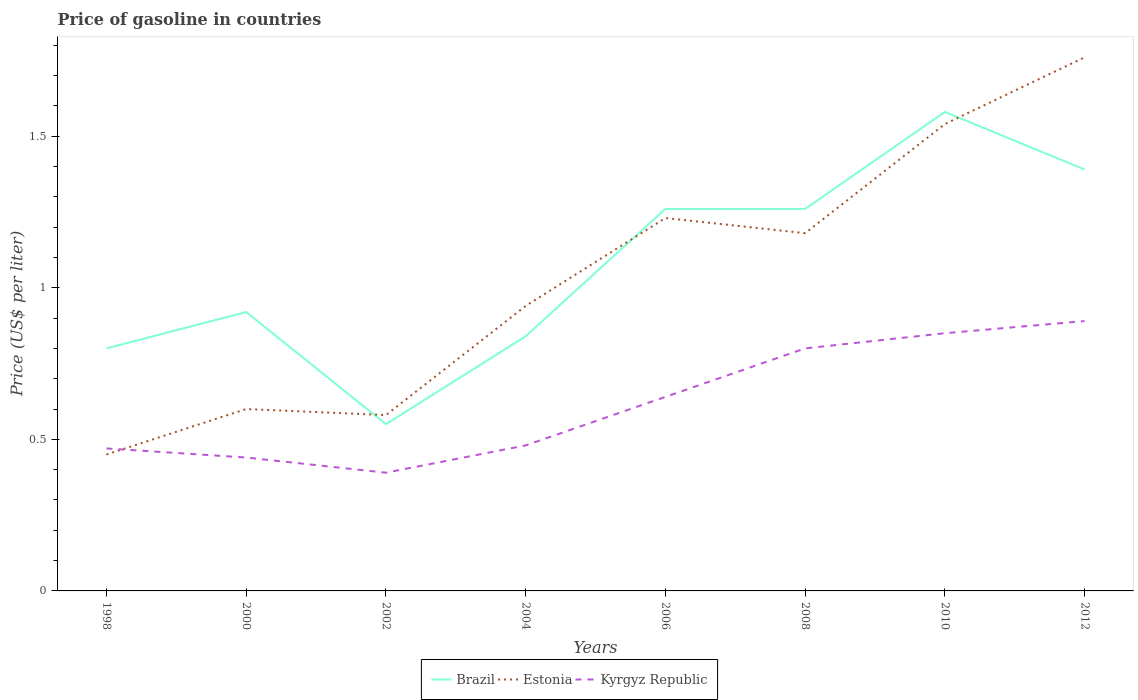How many different coloured lines are there?
Make the answer very short. 3. Does the line corresponding to Kyrgyz Republic intersect with the line corresponding to Estonia?
Your answer should be very brief. Yes. Is the number of lines equal to the number of legend labels?
Provide a short and direct response. Yes. Across all years, what is the maximum price of gasoline in Estonia?
Offer a very short reply. 0.45. In which year was the price of gasoline in Kyrgyz Republic maximum?
Your answer should be very brief. 2002. What is the total price of gasoline in Estonia in the graph?
Provide a short and direct response. -0.65. What is the difference between the highest and the second highest price of gasoline in Kyrgyz Republic?
Offer a very short reply. 0.5. Is the price of gasoline in Brazil strictly greater than the price of gasoline in Estonia over the years?
Make the answer very short. No. How many years are there in the graph?
Your answer should be compact. 8. Does the graph contain grids?
Offer a very short reply. No. Where does the legend appear in the graph?
Offer a very short reply. Bottom center. How many legend labels are there?
Your answer should be very brief. 3. How are the legend labels stacked?
Your response must be concise. Horizontal. What is the title of the graph?
Provide a short and direct response. Price of gasoline in countries. Does "Cambodia" appear as one of the legend labels in the graph?
Keep it short and to the point. No. What is the label or title of the Y-axis?
Provide a succinct answer. Price (US$ per liter). What is the Price (US$ per liter) of Estonia in 1998?
Give a very brief answer. 0.45. What is the Price (US$ per liter) in Kyrgyz Republic in 1998?
Ensure brevity in your answer.  0.47. What is the Price (US$ per liter) of Kyrgyz Republic in 2000?
Keep it short and to the point. 0.44. What is the Price (US$ per liter) in Brazil in 2002?
Offer a very short reply. 0.55. What is the Price (US$ per liter) in Estonia in 2002?
Offer a terse response. 0.58. What is the Price (US$ per liter) in Kyrgyz Republic in 2002?
Give a very brief answer. 0.39. What is the Price (US$ per liter) in Brazil in 2004?
Your response must be concise. 0.84. What is the Price (US$ per liter) of Kyrgyz Republic in 2004?
Keep it short and to the point. 0.48. What is the Price (US$ per liter) of Brazil in 2006?
Give a very brief answer. 1.26. What is the Price (US$ per liter) in Estonia in 2006?
Your answer should be compact. 1.23. What is the Price (US$ per liter) of Kyrgyz Republic in 2006?
Your answer should be compact. 0.64. What is the Price (US$ per liter) of Brazil in 2008?
Offer a terse response. 1.26. What is the Price (US$ per liter) in Estonia in 2008?
Your answer should be compact. 1.18. What is the Price (US$ per liter) of Brazil in 2010?
Keep it short and to the point. 1.58. What is the Price (US$ per liter) in Estonia in 2010?
Provide a succinct answer. 1.54. What is the Price (US$ per liter) in Kyrgyz Republic in 2010?
Provide a succinct answer. 0.85. What is the Price (US$ per liter) of Brazil in 2012?
Your answer should be compact. 1.39. What is the Price (US$ per liter) of Estonia in 2012?
Keep it short and to the point. 1.76. What is the Price (US$ per liter) in Kyrgyz Republic in 2012?
Offer a terse response. 0.89. Across all years, what is the maximum Price (US$ per liter) of Brazil?
Your answer should be compact. 1.58. Across all years, what is the maximum Price (US$ per liter) of Estonia?
Keep it short and to the point. 1.76. Across all years, what is the maximum Price (US$ per liter) of Kyrgyz Republic?
Ensure brevity in your answer.  0.89. Across all years, what is the minimum Price (US$ per liter) in Brazil?
Offer a very short reply. 0.55. Across all years, what is the minimum Price (US$ per liter) of Estonia?
Make the answer very short. 0.45. Across all years, what is the minimum Price (US$ per liter) of Kyrgyz Republic?
Ensure brevity in your answer.  0.39. What is the total Price (US$ per liter) in Brazil in the graph?
Keep it short and to the point. 8.6. What is the total Price (US$ per liter) in Estonia in the graph?
Your answer should be compact. 8.28. What is the total Price (US$ per liter) in Kyrgyz Republic in the graph?
Offer a very short reply. 4.96. What is the difference between the Price (US$ per liter) of Brazil in 1998 and that in 2000?
Offer a very short reply. -0.12. What is the difference between the Price (US$ per liter) in Kyrgyz Republic in 1998 and that in 2000?
Keep it short and to the point. 0.03. What is the difference between the Price (US$ per liter) in Brazil in 1998 and that in 2002?
Give a very brief answer. 0.25. What is the difference between the Price (US$ per liter) of Estonia in 1998 and that in 2002?
Offer a terse response. -0.13. What is the difference between the Price (US$ per liter) in Kyrgyz Republic in 1998 and that in 2002?
Make the answer very short. 0.08. What is the difference between the Price (US$ per liter) in Brazil in 1998 and that in 2004?
Your answer should be compact. -0.04. What is the difference between the Price (US$ per liter) in Estonia in 1998 and that in 2004?
Keep it short and to the point. -0.49. What is the difference between the Price (US$ per liter) of Kyrgyz Republic in 1998 and that in 2004?
Your answer should be compact. -0.01. What is the difference between the Price (US$ per liter) of Brazil in 1998 and that in 2006?
Give a very brief answer. -0.46. What is the difference between the Price (US$ per liter) of Estonia in 1998 and that in 2006?
Your answer should be very brief. -0.78. What is the difference between the Price (US$ per liter) in Kyrgyz Republic in 1998 and that in 2006?
Provide a short and direct response. -0.17. What is the difference between the Price (US$ per liter) in Brazil in 1998 and that in 2008?
Provide a short and direct response. -0.46. What is the difference between the Price (US$ per liter) in Estonia in 1998 and that in 2008?
Keep it short and to the point. -0.73. What is the difference between the Price (US$ per liter) in Kyrgyz Republic in 1998 and that in 2008?
Ensure brevity in your answer.  -0.33. What is the difference between the Price (US$ per liter) in Brazil in 1998 and that in 2010?
Your response must be concise. -0.78. What is the difference between the Price (US$ per liter) in Estonia in 1998 and that in 2010?
Give a very brief answer. -1.09. What is the difference between the Price (US$ per liter) in Kyrgyz Republic in 1998 and that in 2010?
Give a very brief answer. -0.38. What is the difference between the Price (US$ per liter) in Brazil in 1998 and that in 2012?
Offer a terse response. -0.59. What is the difference between the Price (US$ per liter) in Estonia in 1998 and that in 2012?
Offer a terse response. -1.31. What is the difference between the Price (US$ per liter) of Kyrgyz Republic in 1998 and that in 2012?
Provide a succinct answer. -0.42. What is the difference between the Price (US$ per liter) of Brazil in 2000 and that in 2002?
Keep it short and to the point. 0.37. What is the difference between the Price (US$ per liter) of Estonia in 2000 and that in 2002?
Your response must be concise. 0.02. What is the difference between the Price (US$ per liter) of Brazil in 2000 and that in 2004?
Make the answer very short. 0.08. What is the difference between the Price (US$ per liter) of Estonia in 2000 and that in 2004?
Your answer should be compact. -0.34. What is the difference between the Price (US$ per liter) of Kyrgyz Republic in 2000 and that in 2004?
Provide a succinct answer. -0.04. What is the difference between the Price (US$ per liter) of Brazil in 2000 and that in 2006?
Make the answer very short. -0.34. What is the difference between the Price (US$ per liter) in Estonia in 2000 and that in 2006?
Keep it short and to the point. -0.63. What is the difference between the Price (US$ per liter) of Kyrgyz Republic in 2000 and that in 2006?
Your answer should be very brief. -0.2. What is the difference between the Price (US$ per liter) in Brazil in 2000 and that in 2008?
Provide a short and direct response. -0.34. What is the difference between the Price (US$ per liter) of Estonia in 2000 and that in 2008?
Make the answer very short. -0.58. What is the difference between the Price (US$ per liter) in Kyrgyz Republic in 2000 and that in 2008?
Your answer should be compact. -0.36. What is the difference between the Price (US$ per liter) of Brazil in 2000 and that in 2010?
Your response must be concise. -0.66. What is the difference between the Price (US$ per liter) in Estonia in 2000 and that in 2010?
Your response must be concise. -0.94. What is the difference between the Price (US$ per liter) in Kyrgyz Republic in 2000 and that in 2010?
Keep it short and to the point. -0.41. What is the difference between the Price (US$ per liter) in Brazil in 2000 and that in 2012?
Provide a short and direct response. -0.47. What is the difference between the Price (US$ per liter) of Estonia in 2000 and that in 2012?
Your answer should be compact. -1.16. What is the difference between the Price (US$ per liter) in Kyrgyz Republic in 2000 and that in 2012?
Your response must be concise. -0.45. What is the difference between the Price (US$ per liter) of Brazil in 2002 and that in 2004?
Ensure brevity in your answer.  -0.29. What is the difference between the Price (US$ per liter) in Estonia in 2002 and that in 2004?
Make the answer very short. -0.36. What is the difference between the Price (US$ per liter) of Kyrgyz Republic in 2002 and that in 2004?
Keep it short and to the point. -0.09. What is the difference between the Price (US$ per liter) in Brazil in 2002 and that in 2006?
Provide a succinct answer. -0.71. What is the difference between the Price (US$ per liter) in Estonia in 2002 and that in 2006?
Offer a very short reply. -0.65. What is the difference between the Price (US$ per liter) in Brazil in 2002 and that in 2008?
Offer a very short reply. -0.71. What is the difference between the Price (US$ per liter) in Kyrgyz Republic in 2002 and that in 2008?
Provide a succinct answer. -0.41. What is the difference between the Price (US$ per liter) of Brazil in 2002 and that in 2010?
Give a very brief answer. -1.03. What is the difference between the Price (US$ per liter) of Estonia in 2002 and that in 2010?
Ensure brevity in your answer.  -0.96. What is the difference between the Price (US$ per liter) of Kyrgyz Republic in 2002 and that in 2010?
Ensure brevity in your answer.  -0.46. What is the difference between the Price (US$ per liter) in Brazil in 2002 and that in 2012?
Offer a terse response. -0.84. What is the difference between the Price (US$ per liter) in Estonia in 2002 and that in 2012?
Offer a very short reply. -1.18. What is the difference between the Price (US$ per liter) of Brazil in 2004 and that in 2006?
Provide a succinct answer. -0.42. What is the difference between the Price (US$ per liter) in Estonia in 2004 and that in 2006?
Your answer should be very brief. -0.29. What is the difference between the Price (US$ per liter) of Kyrgyz Republic in 2004 and that in 2006?
Your answer should be very brief. -0.16. What is the difference between the Price (US$ per liter) of Brazil in 2004 and that in 2008?
Your answer should be very brief. -0.42. What is the difference between the Price (US$ per liter) in Estonia in 2004 and that in 2008?
Provide a succinct answer. -0.24. What is the difference between the Price (US$ per liter) of Kyrgyz Republic in 2004 and that in 2008?
Your response must be concise. -0.32. What is the difference between the Price (US$ per liter) of Brazil in 2004 and that in 2010?
Your answer should be compact. -0.74. What is the difference between the Price (US$ per liter) in Estonia in 2004 and that in 2010?
Your response must be concise. -0.6. What is the difference between the Price (US$ per liter) in Kyrgyz Republic in 2004 and that in 2010?
Offer a very short reply. -0.37. What is the difference between the Price (US$ per liter) in Brazil in 2004 and that in 2012?
Offer a very short reply. -0.55. What is the difference between the Price (US$ per liter) of Estonia in 2004 and that in 2012?
Make the answer very short. -0.82. What is the difference between the Price (US$ per liter) in Kyrgyz Republic in 2004 and that in 2012?
Ensure brevity in your answer.  -0.41. What is the difference between the Price (US$ per liter) of Brazil in 2006 and that in 2008?
Provide a succinct answer. 0. What is the difference between the Price (US$ per liter) in Kyrgyz Republic in 2006 and that in 2008?
Provide a short and direct response. -0.16. What is the difference between the Price (US$ per liter) of Brazil in 2006 and that in 2010?
Your answer should be very brief. -0.32. What is the difference between the Price (US$ per liter) in Estonia in 2006 and that in 2010?
Your answer should be compact. -0.31. What is the difference between the Price (US$ per liter) of Kyrgyz Republic in 2006 and that in 2010?
Ensure brevity in your answer.  -0.21. What is the difference between the Price (US$ per liter) of Brazil in 2006 and that in 2012?
Provide a short and direct response. -0.13. What is the difference between the Price (US$ per liter) of Estonia in 2006 and that in 2012?
Your response must be concise. -0.53. What is the difference between the Price (US$ per liter) of Kyrgyz Republic in 2006 and that in 2012?
Give a very brief answer. -0.25. What is the difference between the Price (US$ per liter) in Brazil in 2008 and that in 2010?
Keep it short and to the point. -0.32. What is the difference between the Price (US$ per liter) of Estonia in 2008 and that in 2010?
Offer a very short reply. -0.36. What is the difference between the Price (US$ per liter) of Brazil in 2008 and that in 2012?
Your answer should be compact. -0.13. What is the difference between the Price (US$ per liter) in Estonia in 2008 and that in 2012?
Provide a succinct answer. -0.58. What is the difference between the Price (US$ per liter) in Kyrgyz Republic in 2008 and that in 2012?
Keep it short and to the point. -0.09. What is the difference between the Price (US$ per liter) in Brazil in 2010 and that in 2012?
Offer a terse response. 0.19. What is the difference between the Price (US$ per liter) of Estonia in 2010 and that in 2012?
Offer a very short reply. -0.22. What is the difference between the Price (US$ per liter) of Kyrgyz Republic in 2010 and that in 2012?
Your response must be concise. -0.04. What is the difference between the Price (US$ per liter) in Brazil in 1998 and the Price (US$ per liter) in Kyrgyz Republic in 2000?
Your answer should be very brief. 0.36. What is the difference between the Price (US$ per liter) in Estonia in 1998 and the Price (US$ per liter) in Kyrgyz Republic in 2000?
Provide a short and direct response. 0.01. What is the difference between the Price (US$ per liter) of Brazil in 1998 and the Price (US$ per liter) of Estonia in 2002?
Offer a terse response. 0.22. What is the difference between the Price (US$ per liter) of Brazil in 1998 and the Price (US$ per liter) of Kyrgyz Republic in 2002?
Offer a very short reply. 0.41. What is the difference between the Price (US$ per liter) in Estonia in 1998 and the Price (US$ per liter) in Kyrgyz Republic in 2002?
Ensure brevity in your answer.  0.06. What is the difference between the Price (US$ per liter) in Brazil in 1998 and the Price (US$ per liter) in Estonia in 2004?
Offer a very short reply. -0.14. What is the difference between the Price (US$ per liter) of Brazil in 1998 and the Price (US$ per liter) of Kyrgyz Republic in 2004?
Make the answer very short. 0.32. What is the difference between the Price (US$ per liter) in Estonia in 1998 and the Price (US$ per liter) in Kyrgyz Republic in 2004?
Keep it short and to the point. -0.03. What is the difference between the Price (US$ per liter) of Brazil in 1998 and the Price (US$ per liter) of Estonia in 2006?
Give a very brief answer. -0.43. What is the difference between the Price (US$ per liter) of Brazil in 1998 and the Price (US$ per liter) of Kyrgyz Republic in 2006?
Your answer should be very brief. 0.16. What is the difference between the Price (US$ per liter) of Estonia in 1998 and the Price (US$ per liter) of Kyrgyz Republic in 2006?
Offer a very short reply. -0.19. What is the difference between the Price (US$ per liter) of Brazil in 1998 and the Price (US$ per liter) of Estonia in 2008?
Provide a short and direct response. -0.38. What is the difference between the Price (US$ per liter) in Estonia in 1998 and the Price (US$ per liter) in Kyrgyz Republic in 2008?
Ensure brevity in your answer.  -0.35. What is the difference between the Price (US$ per liter) of Brazil in 1998 and the Price (US$ per liter) of Estonia in 2010?
Keep it short and to the point. -0.74. What is the difference between the Price (US$ per liter) in Brazil in 1998 and the Price (US$ per liter) in Estonia in 2012?
Ensure brevity in your answer.  -0.96. What is the difference between the Price (US$ per liter) in Brazil in 1998 and the Price (US$ per liter) in Kyrgyz Republic in 2012?
Your answer should be very brief. -0.09. What is the difference between the Price (US$ per liter) in Estonia in 1998 and the Price (US$ per liter) in Kyrgyz Republic in 2012?
Ensure brevity in your answer.  -0.44. What is the difference between the Price (US$ per liter) in Brazil in 2000 and the Price (US$ per liter) in Estonia in 2002?
Make the answer very short. 0.34. What is the difference between the Price (US$ per liter) of Brazil in 2000 and the Price (US$ per liter) of Kyrgyz Republic in 2002?
Your response must be concise. 0.53. What is the difference between the Price (US$ per liter) of Estonia in 2000 and the Price (US$ per liter) of Kyrgyz Republic in 2002?
Make the answer very short. 0.21. What is the difference between the Price (US$ per liter) of Brazil in 2000 and the Price (US$ per liter) of Estonia in 2004?
Provide a short and direct response. -0.02. What is the difference between the Price (US$ per liter) in Brazil in 2000 and the Price (US$ per liter) in Kyrgyz Republic in 2004?
Make the answer very short. 0.44. What is the difference between the Price (US$ per liter) of Estonia in 2000 and the Price (US$ per liter) of Kyrgyz Republic in 2004?
Give a very brief answer. 0.12. What is the difference between the Price (US$ per liter) of Brazil in 2000 and the Price (US$ per liter) of Estonia in 2006?
Provide a succinct answer. -0.31. What is the difference between the Price (US$ per liter) of Brazil in 2000 and the Price (US$ per liter) of Kyrgyz Republic in 2006?
Your answer should be very brief. 0.28. What is the difference between the Price (US$ per liter) of Estonia in 2000 and the Price (US$ per liter) of Kyrgyz Republic in 2006?
Your answer should be very brief. -0.04. What is the difference between the Price (US$ per liter) in Brazil in 2000 and the Price (US$ per liter) in Estonia in 2008?
Your response must be concise. -0.26. What is the difference between the Price (US$ per liter) of Brazil in 2000 and the Price (US$ per liter) of Kyrgyz Republic in 2008?
Your answer should be very brief. 0.12. What is the difference between the Price (US$ per liter) in Estonia in 2000 and the Price (US$ per liter) in Kyrgyz Republic in 2008?
Your answer should be compact. -0.2. What is the difference between the Price (US$ per liter) in Brazil in 2000 and the Price (US$ per liter) in Estonia in 2010?
Offer a terse response. -0.62. What is the difference between the Price (US$ per liter) of Brazil in 2000 and the Price (US$ per liter) of Kyrgyz Republic in 2010?
Make the answer very short. 0.07. What is the difference between the Price (US$ per liter) of Estonia in 2000 and the Price (US$ per liter) of Kyrgyz Republic in 2010?
Your response must be concise. -0.25. What is the difference between the Price (US$ per liter) of Brazil in 2000 and the Price (US$ per liter) of Estonia in 2012?
Ensure brevity in your answer.  -0.84. What is the difference between the Price (US$ per liter) of Estonia in 2000 and the Price (US$ per liter) of Kyrgyz Republic in 2012?
Your response must be concise. -0.29. What is the difference between the Price (US$ per liter) of Brazil in 2002 and the Price (US$ per liter) of Estonia in 2004?
Your answer should be very brief. -0.39. What is the difference between the Price (US$ per liter) of Brazil in 2002 and the Price (US$ per liter) of Kyrgyz Republic in 2004?
Ensure brevity in your answer.  0.07. What is the difference between the Price (US$ per liter) in Estonia in 2002 and the Price (US$ per liter) in Kyrgyz Republic in 2004?
Your answer should be compact. 0.1. What is the difference between the Price (US$ per liter) of Brazil in 2002 and the Price (US$ per liter) of Estonia in 2006?
Your answer should be compact. -0.68. What is the difference between the Price (US$ per liter) in Brazil in 2002 and the Price (US$ per liter) in Kyrgyz Republic in 2006?
Ensure brevity in your answer.  -0.09. What is the difference between the Price (US$ per liter) of Estonia in 2002 and the Price (US$ per liter) of Kyrgyz Republic in 2006?
Keep it short and to the point. -0.06. What is the difference between the Price (US$ per liter) of Brazil in 2002 and the Price (US$ per liter) of Estonia in 2008?
Keep it short and to the point. -0.63. What is the difference between the Price (US$ per liter) in Brazil in 2002 and the Price (US$ per liter) in Kyrgyz Republic in 2008?
Your response must be concise. -0.25. What is the difference between the Price (US$ per liter) of Estonia in 2002 and the Price (US$ per liter) of Kyrgyz Republic in 2008?
Offer a terse response. -0.22. What is the difference between the Price (US$ per liter) in Brazil in 2002 and the Price (US$ per liter) in Estonia in 2010?
Your answer should be compact. -0.99. What is the difference between the Price (US$ per liter) of Brazil in 2002 and the Price (US$ per liter) of Kyrgyz Republic in 2010?
Provide a succinct answer. -0.3. What is the difference between the Price (US$ per liter) in Estonia in 2002 and the Price (US$ per liter) in Kyrgyz Republic in 2010?
Offer a very short reply. -0.27. What is the difference between the Price (US$ per liter) in Brazil in 2002 and the Price (US$ per liter) in Estonia in 2012?
Make the answer very short. -1.21. What is the difference between the Price (US$ per liter) of Brazil in 2002 and the Price (US$ per liter) of Kyrgyz Republic in 2012?
Your response must be concise. -0.34. What is the difference between the Price (US$ per liter) of Estonia in 2002 and the Price (US$ per liter) of Kyrgyz Republic in 2012?
Provide a short and direct response. -0.31. What is the difference between the Price (US$ per liter) of Brazil in 2004 and the Price (US$ per liter) of Estonia in 2006?
Keep it short and to the point. -0.39. What is the difference between the Price (US$ per liter) of Brazil in 2004 and the Price (US$ per liter) of Kyrgyz Republic in 2006?
Give a very brief answer. 0.2. What is the difference between the Price (US$ per liter) of Brazil in 2004 and the Price (US$ per liter) of Estonia in 2008?
Offer a very short reply. -0.34. What is the difference between the Price (US$ per liter) of Estonia in 2004 and the Price (US$ per liter) of Kyrgyz Republic in 2008?
Give a very brief answer. 0.14. What is the difference between the Price (US$ per liter) of Brazil in 2004 and the Price (US$ per liter) of Estonia in 2010?
Give a very brief answer. -0.7. What is the difference between the Price (US$ per liter) in Brazil in 2004 and the Price (US$ per liter) in Kyrgyz Republic in 2010?
Provide a succinct answer. -0.01. What is the difference between the Price (US$ per liter) of Estonia in 2004 and the Price (US$ per liter) of Kyrgyz Republic in 2010?
Your answer should be very brief. 0.09. What is the difference between the Price (US$ per liter) in Brazil in 2004 and the Price (US$ per liter) in Estonia in 2012?
Offer a terse response. -0.92. What is the difference between the Price (US$ per liter) in Brazil in 2004 and the Price (US$ per liter) in Kyrgyz Republic in 2012?
Give a very brief answer. -0.05. What is the difference between the Price (US$ per liter) in Estonia in 2004 and the Price (US$ per liter) in Kyrgyz Republic in 2012?
Your answer should be compact. 0.05. What is the difference between the Price (US$ per liter) in Brazil in 2006 and the Price (US$ per liter) in Kyrgyz Republic in 2008?
Keep it short and to the point. 0.46. What is the difference between the Price (US$ per liter) in Estonia in 2006 and the Price (US$ per liter) in Kyrgyz Republic in 2008?
Provide a succinct answer. 0.43. What is the difference between the Price (US$ per liter) of Brazil in 2006 and the Price (US$ per liter) of Estonia in 2010?
Your response must be concise. -0.28. What is the difference between the Price (US$ per liter) of Brazil in 2006 and the Price (US$ per liter) of Kyrgyz Republic in 2010?
Your response must be concise. 0.41. What is the difference between the Price (US$ per liter) in Estonia in 2006 and the Price (US$ per liter) in Kyrgyz Republic in 2010?
Your answer should be very brief. 0.38. What is the difference between the Price (US$ per liter) of Brazil in 2006 and the Price (US$ per liter) of Estonia in 2012?
Make the answer very short. -0.5. What is the difference between the Price (US$ per liter) in Brazil in 2006 and the Price (US$ per liter) in Kyrgyz Republic in 2012?
Keep it short and to the point. 0.37. What is the difference between the Price (US$ per liter) in Estonia in 2006 and the Price (US$ per liter) in Kyrgyz Republic in 2012?
Make the answer very short. 0.34. What is the difference between the Price (US$ per liter) of Brazil in 2008 and the Price (US$ per liter) of Estonia in 2010?
Your answer should be compact. -0.28. What is the difference between the Price (US$ per liter) in Brazil in 2008 and the Price (US$ per liter) in Kyrgyz Republic in 2010?
Your response must be concise. 0.41. What is the difference between the Price (US$ per liter) in Estonia in 2008 and the Price (US$ per liter) in Kyrgyz Republic in 2010?
Offer a terse response. 0.33. What is the difference between the Price (US$ per liter) in Brazil in 2008 and the Price (US$ per liter) in Estonia in 2012?
Make the answer very short. -0.5. What is the difference between the Price (US$ per liter) of Brazil in 2008 and the Price (US$ per liter) of Kyrgyz Republic in 2012?
Provide a succinct answer. 0.37. What is the difference between the Price (US$ per liter) of Estonia in 2008 and the Price (US$ per liter) of Kyrgyz Republic in 2012?
Your response must be concise. 0.29. What is the difference between the Price (US$ per liter) of Brazil in 2010 and the Price (US$ per liter) of Estonia in 2012?
Provide a short and direct response. -0.18. What is the difference between the Price (US$ per liter) in Brazil in 2010 and the Price (US$ per liter) in Kyrgyz Republic in 2012?
Provide a succinct answer. 0.69. What is the difference between the Price (US$ per liter) in Estonia in 2010 and the Price (US$ per liter) in Kyrgyz Republic in 2012?
Offer a terse response. 0.65. What is the average Price (US$ per liter) of Brazil per year?
Your answer should be compact. 1.07. What is the average Price (US$ per liter) of Estonia per year?
Keep it short and to the point. 1.03. What is the average Price (US$ per liter) in Kyrgyz Republic per year?
Your answer should be very brief. 0.62. In the year 1998, what is the difference between the Price (US$ per liter) in Brazil and Price (US$ per liter) in Estonia?
Offer a very short reply. 0.35. In the year 1998, what is the difference between the Price (US$ per liter) of Brazil and Price (US$ per liter) of Kyrgyz Republic?
Provide a succinct answer. 0.33. In the year 1998, what is the difference between the Price (US$ per liter) of Estonia and Price (US$ per liter) of Kyrgyz Republic?
Give a very brief answer. -0.02. In the year 2000, what is the difference between the Price (US$ per liter) of Brazil and Price (US$ per liter) of Estonia?
Provide a short and direct response. 0.32. In the year 2000, what is the difference between the Price (US$ per liter) of Brazil and Price (US$ per liter) of Kyrgyz Republic?
Provide a succinct answer. 0.48. In the year 2000, what is the difference between the Price (US$ per liter) of Estonia and Price (US$ per liter) of Kyrgyz Republic?
Ensure brevity in your answer.  0.16. In the year 2002, what is the difference between the Price (US$ per liter) of Brazil and Price (US$ per liter) of Estonia?
Provide a short and direct response. -0.03. In the year 2002, what is the difference between the Price (US$ per liter) of Brazil and Price (US$ per liter) of Kyrgyz Republic?
Your response must be concise. 0.16. In the year 2002, what is the difference between the Price (US$ per liter) of Estonia and Price (US$ per liter) of Kyrgyz Republic?
Provide a succinct answer. 0.19. In the year 2004, what is the difference between the Price (US$ per liter) of Brazil and Price (US$ per liter) of Estonia?
Provide a succinct answer. -0.1. In the year 2004, what is the difference between the Price (US$ per liter) of Brazil and Price (US$ per liter) of Kyrgyz Republic?
Make the answer very short. 0.36. In the year 2004, what is the difference between the Price (US$ per liter) of Estonia and Price (US$ per liter) of Kyrgyz Republic?
Give a very brief answer. 0.46. In the year 2006, what is the difference between the Price (US$ per liter) in Brazil and Price (US$ per liter) in Estonia?
Keep it short and to the point. 0.03. In the year 2006, what is the difference between the Price (US$ per liter) in Brazil and Price (US$ per liter) in Kyrgyz Republic?
Your response must be concise. 0.62. In the year 2006, what is the difference between the Price (US$ per liter) in Estonia and Price (US$ per liter) in Kyrgyz Republic?
Ensure brevity in your answer.  0.59. In the year 2008, what is the difference between the Price (US$ per liter) of Brazil and Price (US$ per liter) of Kyrgyz Republic?
Offer a terse response. 0.46. In the year 2008, what is the difference between the Price (US$ per liter) of Estonia and Price (US$ per liter) of Kyrgyz Republic?
Your response must be concise. 0.38. In the year 2010, what is the difference between the Price (US$ per liter) of Brazil and Price (US$ per liter) of Kyrgyz Republic?
Provide a short and direct response. 0.73. In the year 2010, what is the difference between the Price (US$ per liter) in Estonia and Price (US$ per liter) in Kyrgyz Republic?
Your answer should be very brief. 0.69. In the year 2012, what is the difference between the Price (US$ per liter) of Brazil and Price (US$ per liter) of Estonia?
Make the answer very short. -0.37. In the year 2012, what is the difference between the Price (US$ per liter) of Estonia and Price (US$ per liter) of Kyrgyz Republic?
Your response must be concise. 0.87. What is the ratio of the Price (US$ per liter) of Brazil in 1998 to that in 2000?
Your answer should be compact. 0.87. What is the ratio of the Price (US$ per liter) of Estonia in 1998 to that in 2000?
Offer a very short reply. 0.75. What is the ratio of the Price (US$ per liter) of Kyrgyz Republic in 1998 to that in 2000?
Give a very brief answer. 1.07. What is the ratio of the Price (US$ per liter) of Brazil in 1998 to that in 2002?
Your response must be concise. 1.45. What is the ratio of the Price (US$ per liter) in Estonia in 1998 to that in 2002?
Give a very brief answer. 0.78. What is the ratio of the Price (US$ per liter) in Kyrgyz Republic in 1998 to that in 2002?
Make the answer very short. 1.21. What is the ratio of the Price (US$ per liter) of Brazil in 1998 to that in 2004?
Make the answer very short. 0.95. What is the ratio of the Price (US$ per liter) of Estonia in 1998 to that in 2004?
Offer a very short reply. 0.48. What is the ratio of the Price (US$ per liter) in Kyrgyz Republic in 1998 to that in 2004?
Offer a terse response. 0.98. What is the ratio of the Price (US$ per liter) of Brazil in 1998 to that in 2006?
Your response must be concise. 0.63. What is the ratio of the Price (US$ per liter) in Estonia in 1998 to that in 2006?
Provide a short and direct response. 0.37. What is the ratio of the Price (US$ per liter) of Kyrgyz Republic in 1998 to that in 2006?
Ensure brevity in your answer.  0.73. What is the ratio of the Price (US$ per liter) of Brazil in 1998 to that in 2008?
Your response must be concise. 0.63. What is the ratio of the Price (US$ per liter) in Estonia in 1998 to that in 2008?
Offer a very short reply. 0.38. What is the ratio of the Price (US$ per liter) in Kyrgyz Republic in 1998 to that in 2008?
Keep it short and to the point. 0.59. What is the ratio of the Price (US$ per liter) of Brazil in 1998 to that in 2010?
Give a very brief answer. 0.51. What is the ratio of the Price (US$ per liter) in Estonia in 1998 to that in 2010?
Offer a very short reply. 0.29. What is the ratio of the Price (US$ per liter) of Kyrgyz Republic in 1998 to that in 2010?
Ensure brevity in your answer.  0.55. What is the ratio of the Price (US$ per liter) in Brazil in 1998 to that in 2012?
Offer a terse response. 0.58. What is the ratio of the Price (US$ per liter) in Estonia in 1998 to that in 2012?
Your answer should be compact. 0.26. What is the ratio of the Price (US$ per liter) of Kyrgyz Republic in 1998 to that in 2012?
Your response must be concise. 0.53. What is the ratio of the Price (US$ per liter) in Brazil in 2000 to that in 2002?
Provide a succinct answer. 1.67. What is the ratio of the Price (US$ per liter) of Estonia in 2000 to that in 2002?
Provide a succinct answer. 1.03. What is the ratio of the Price (US$ per liter) in Kyrgyz Republic in 2000 to that in 2002?
Give a very brief answer. 1.13. What is the ratio of the Price (US$ per liter) in Brazil in 2000 to that in 2004?
Offer a very short reply. 1.1. What is the ratio of the Price (US$ per liter) in Estonia in 2000 to that in 2004?
Keep it short and to the point. 0.64. What is the ratio of the Price (US$ per liter) in Brazil in 2000 to that in 2006?
Give a very brief answer. 0.73. What is the ratio of the Price (US$ per liter) in Estonia in 2000 to that in 2006?
Your response must be concise. 0.49. What is the ratio of the Price (US$ per liter) of Kyrgyz Republic in 2000 to that in 2006?
Offer a terse response. 0.69. What is the ratio of the Price (US$ per liter) of Brazil in 2000 to that in 2008?
Make the answer very short. 0.73. What is the ratio of the Price (US$ per liter) in Estonia in 2000 to that in 2008?
Provide a succinct answer. 0.51. What is the ratio of the Price (US$ per liter) in Kyrgyz Republic in 2000 to that in 2008?
Keep it short and to the point. 0.55. What is the ratio of the Price (US$ per liter) of Brazil in 2000 to that in 2010?
Offer a very short reply. 0.58. What is the ratio of the Price (US$ per liter) in Estonia in 2000 to that in 2010?
Offer a very short reply. 0.39. What is the ratio of the Price (US$ per liter) in Kyrgyz Republic in 2000 to that in 2010?
Offer a terse response. 0.52. What is the ratio of the Price (US$ per liter) in Brazil in 2000 to that in 2012?
Offer a terse response. 0.66. What is the ratio of the Price (US$ per liter) in Estonia in 2000 to that in 2012?
Offer a very short reply. 0.34. What is the ratio of the Price (US$ per liter) in Kyrgyz Republic in 2000 to that in 2012?
Provide a succinct answer. 0.49. What is the ratio of the Price (US$ per liter) of Brazil in 2002 to that in 2004?
Keep it short and to the point. 0.65. What is the ratio of the Price (US$ per liter) in Estonia in 2002 to that in 2004?
Your response must be concise. 0.62. What is the ratio of the Price (US$ per liter) in Kyrgyz Republic in 2002 to that in 2004?
Make the answer very short. 0.81. What is the ratio of the Price (US$ per liter) of Brazil in 2002 to that in 2006?
Your answer should be compact. 0.44. What is the ratio of the Price (US$ per liter) in Estonia in 2002 to that in 2006?
Your answer should be very brief. 0.47. What is the ratio of the Price (US$ per liter) of Kyrgyz Republic in 2002 to that in 2006?
Make the answer very short. 0.61. What is the ratio of the Price (US$ per liter) in Brazil in 2002 to that in 2008?
Offer a very short reply. 0.44. What is the ratio of the Price (US$ per liter) of Estonia in 2002 to that in 2008?
Give a very brief answer. 0.49. What is the ratio of the Price (US$ per liter) in Kyrgyz Republic in 2002 to that in 2008?
Provide a succinct answer. 0.49. What is the ratio of the Price (US$ per liter) in Brazil in 2002 to that in 2010?
Offer a very short reply. 0.35. What is the ratio of the Price (US$ per liter) in Estonia in 2002 to that in 2010?
Ensure brevity in your answer.  0.38. What is the ratio of the Price (US$ per liter) in Kyrgyz Republic in 2002 to that in 2010?
Provide a succinct answer. 0.46. What is the ratio of the Price (US$ per liter) in Brazil in 2002 to that in 2012?
Keep it short and to the point. 0.4. What is the ratio of the Price (US$ per liter) of Estonia in 2002 to that in 2012?
Make the answer very short. 0.33. What is the ratio of the Price (US$ per liter) in Kyrgyz Republic in 2002 to that in 2012?
Keep it short and to the point. 0.44. What is the ratio of the Price (US$ per liter) of Estonia in 2004 to that in 2006?
Make the answer very short. 0.76. What is the ratio of the Price (US$ per liter) in Estonia in 2004 to that in 2008?
Your answer should be compact. 0.8. What is the ratio of the Price (US$ per liter) in Brazil in 2004 to that in 2010?
Your answer should be compact. 0.53. What is the ratio of the Price (US$ per liter) of Estonia in 2004 to that in 2010?
Ensure brevity in your answer.  0.61. What is the ratio of the Price (US$ per liter) in Kyrgyz Republic in 2004 to that in 2010?
Your response must be concise. 0.56. What is the ratio of the Price (US$ per liter) in Brazil in 2004 to that in 2012?
Make the answer very short. 0.6. What is the ratio of the Price (US$ per liter) in Estonia in 2004 to that in 2012?
Provide a succinct answer. 0.53. What is the ratio of the Price (US$ per liter) in Kyrgyz Republic in 2004 to that in 2012?
Your answer should be compact. 0.54. What is the ratio of the Price (US$ per liter) of Brazil in 2006 to that in 2008?
Keep it short and to the point. 1. What is the ratio of the Price (US$ per liter) in Estonia in 2006 to that in 2008?
Your answer should be compact. 1.04. What is the ratio of the Price (US$ per liter) of Kyrgyz Republic in 2006 to that in 2008?
Provide a short and direct response. 0.8. What is the ratio of the Price (US$ per liter) of Brazil in 2006 to that in 2010?
Provide a short and direct response. 0.8. What is the ratio of the Price (US$ per liter) in Estonia in 2006 to that in 2010?
Your answer should be very brief. 0.8. What is the ratio of the Price (US$ per liter) of Kyrgyz Republic in 2006 to that in 2010?
Your answer should be very brief. 0.75. What is the ratio of the Price (US$ per liter) in Brazil in 2006 to that in 2012?
Your answer should be very brief. 0.91. What is the ratio of the Price (US$ per liter) in Estonia in 2006 to that in 2012?
Ensure brevity in your answer.  0.7. What is the ratio of the Price (US$ per liter) of Kyrgyz Republic in 2006 to that in 2012?
Ensure brevity in your answer.  0.72. What is the ratio of the Price (US$ per liter) of Brazil in 2008 to that in 2010?
Make the answer very short. 0.8. What is the ratio of the Price (US$ per liter) in Estonia in 2008 to that in 2010?
Keep it short and to the point. 0.77. What is the ratio of the Price (US$ per liter) of Brazil in 2008 to that in 2012?
Provide a succinct answer. 0.91. What is the ratio of the Price (US$ per liter) of Estonia in 2008 to that in 2012?
Keep it short and to the point. 0.67. What is the ratio of the Price (US$ per liter) of Kyrgyz Republic in 2008 to that in 2012?
Offer a terse response. 0.9. What is the ratio of the Price (US$ per liter) in Brazil in 2010 to that in 2012?
Your answer should be compact. 1.14. What is the ratio of the Price (US$ per liter) of Estonia in 2010 to that in 2012?
Keep it short and to the point. 0.88. What is the ratio of the Price (US$ per liter) in Kyrgyz Republic in 2010 to that in 2012?
Your answer should be compact. 0.96. What is the difference between the highest and the second highest Price (US$ per liter) in Brazil?
Offer a terse response. 0.19. What is the difference between the highest and the second highest Price (US$ per liter) of Estonia?
Your response must be concise. 0.22. What is the difference between the highest and the lowest Price (US$ per liter) in Brazil?
Keep it short and to the point. 1.03. What is the difference between the highest and the lowest Price (US$ per liter) in Estonia?
Ensure brevity in your answer.  1.31. 